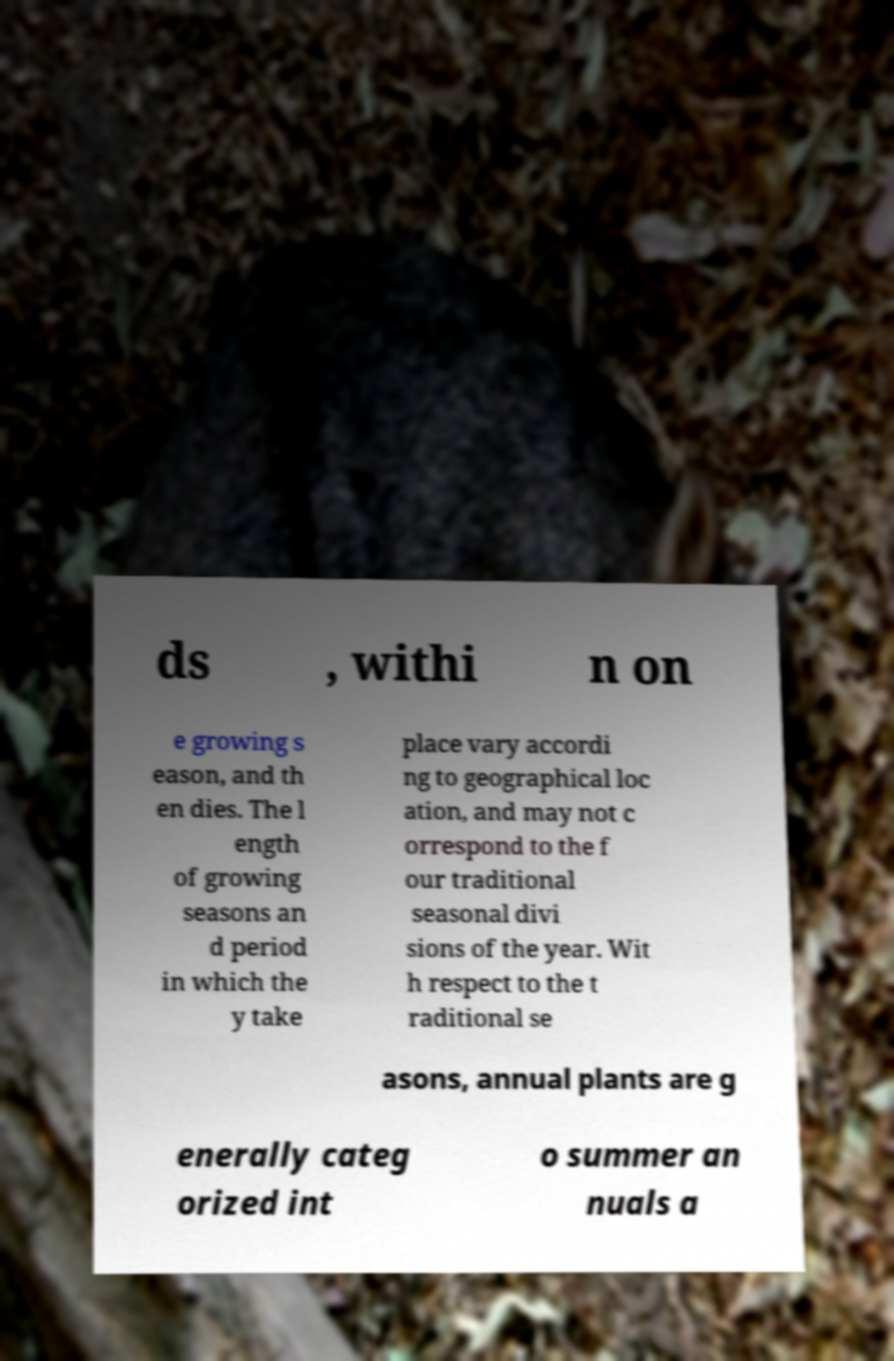Could you extract and type out the text from this image? ds , withi n on e growing s eason, and th en dies. The l ength of growing seasons an d period in which the y take place vary accordi ng to geographical loc ation, and may not c orrespond to the f our traditional seasonal divi sions of the year. Wit h respect to the t raditional se asons, annual plants are g enerally categ orized int o summer an nuals a 